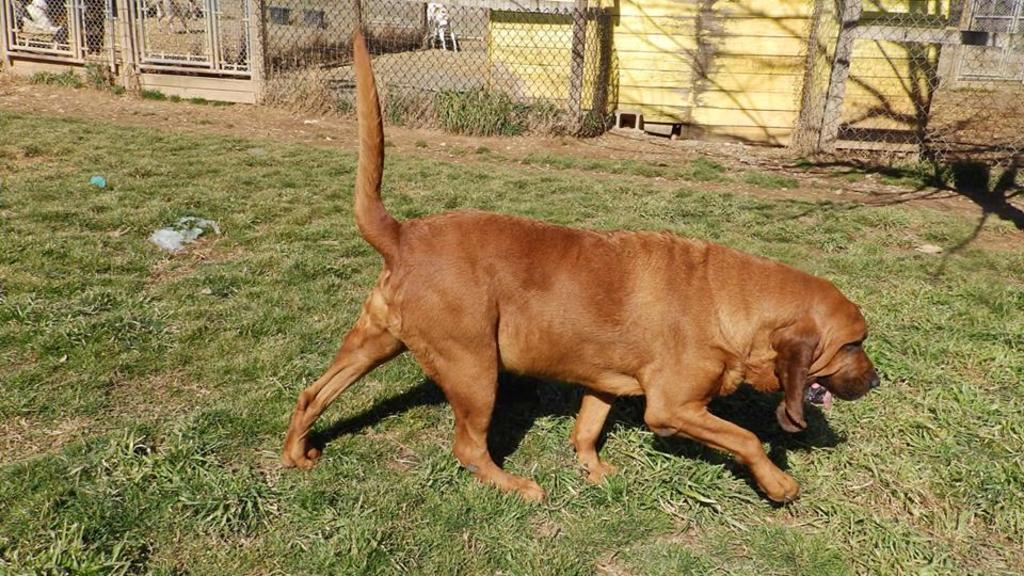What type of animal is in the image? There is a brown color dog in the image. What is the dog doing in the image? The dog is walking on the grass. What can be seen in the background of the image? There is fencing visible in the image. What type of heart-shaped receipt can be seen in the dog's mouth in the image? There is no heart-shaped receipt present in the image, nor is there any indication that the dog has anything in its mouth. 